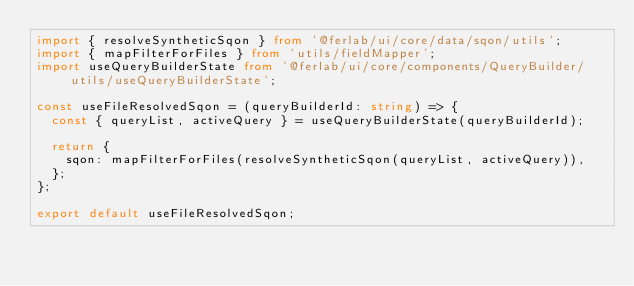Convert code to text. <code><loc_0><loc_0><loc_500><loc_500><_TypeScript_>import { resolveSyntheticSqon } from '@ferlab/ui/core/data/sqon/utils';
import { mapFilterForFiles } from 'utils/fieldMapper';
import useQueryBuilderState from '@ferlab/ui/core/components/QueryBuilder/utils/useQueryBuilderState';

const useFileResolvedSqon = (queryBuilderId: string) => {
  const { queryList, activeQuery } = useQueryBuilderState(queryBuilderId);

  return {
    sqon: mapFilterForFiles(resolveSyntheticSqon(queryList, activeQuery)),
  };
};

export default useFileResolvedSqon;
</code> 